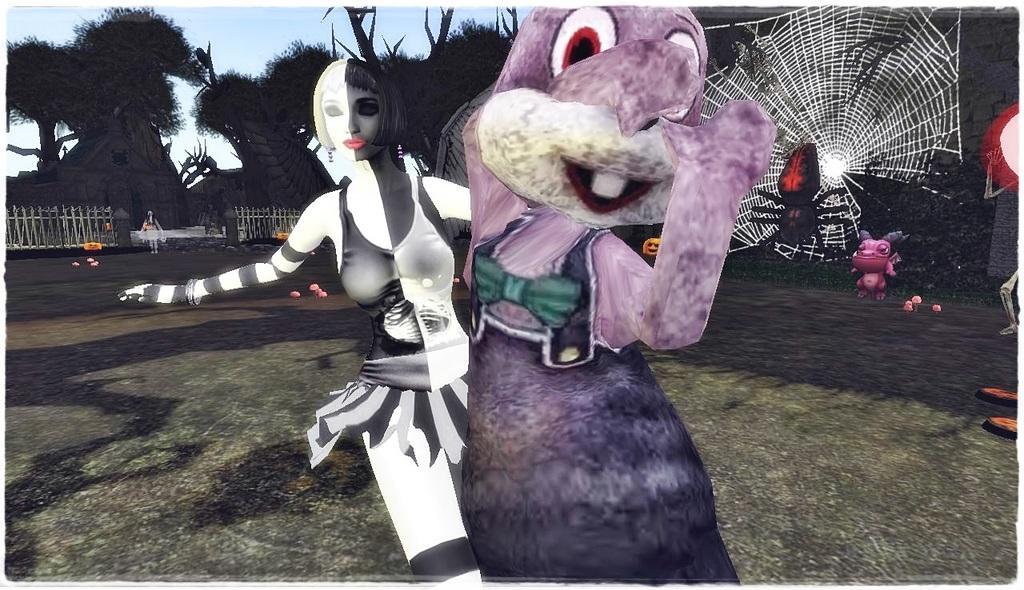In one or two sentences, can you explain what this image depicts? It is a graphical image, in the image we can see a person and animated images, trees and fencing. 